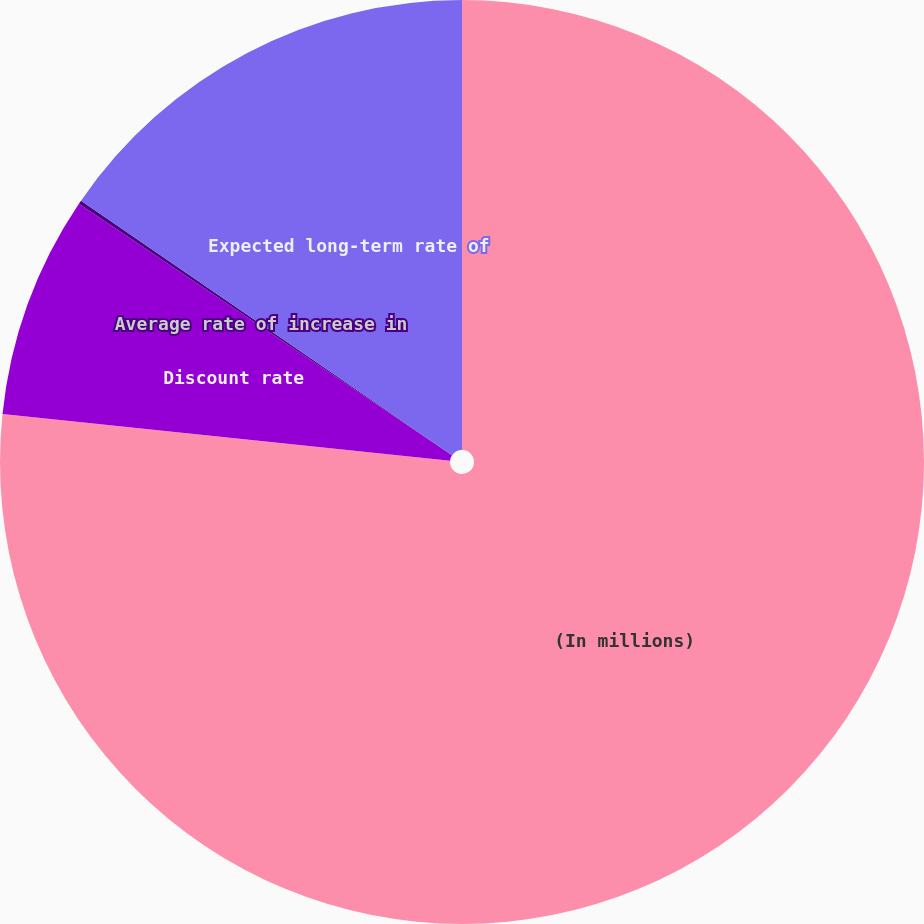Convert chart to OTSL. <chart><loc_0><loc_0><loc_500><loc_500><pie_chart><fcel>(In millions)<fcel>Discount rate<fcel>Average rate of increase in<fcel>Expected long-term rate of<nl><fcel>76.66%<fcel>7.78%<fcel>0.13%<fcel>15.43%<nl></chart> 